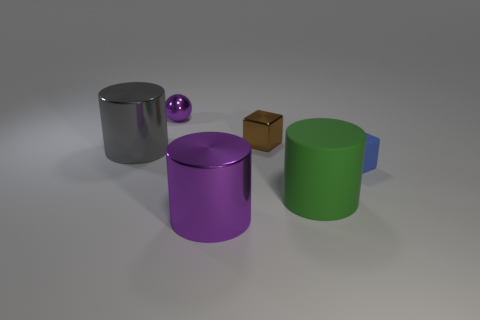Subtract all rubber cylinders. How many cylinders are left? 2 Subtract 1 cylinders. How many cylinders are left? 2 Add 1 tiny blue cubes. How many objects exist? 7 Subtract all blue blocks. How many blocks are left? 1 Subtract all spheres. How many objects are left? 5 Subtract all cyan cylinders. Subtract all brown balls. How many cylinders are left? 3 Subtract 1 gray cylinders. How many objects are left? 5 Subtract all big metal things. Subtract all blue matte things. How many objects are left? 3 Add 1 big purple cylinders. How many big purple cylinders are left? 2 Add 3 large gray rubber cylinders. How many large gray rubber cylinders exist? 3 